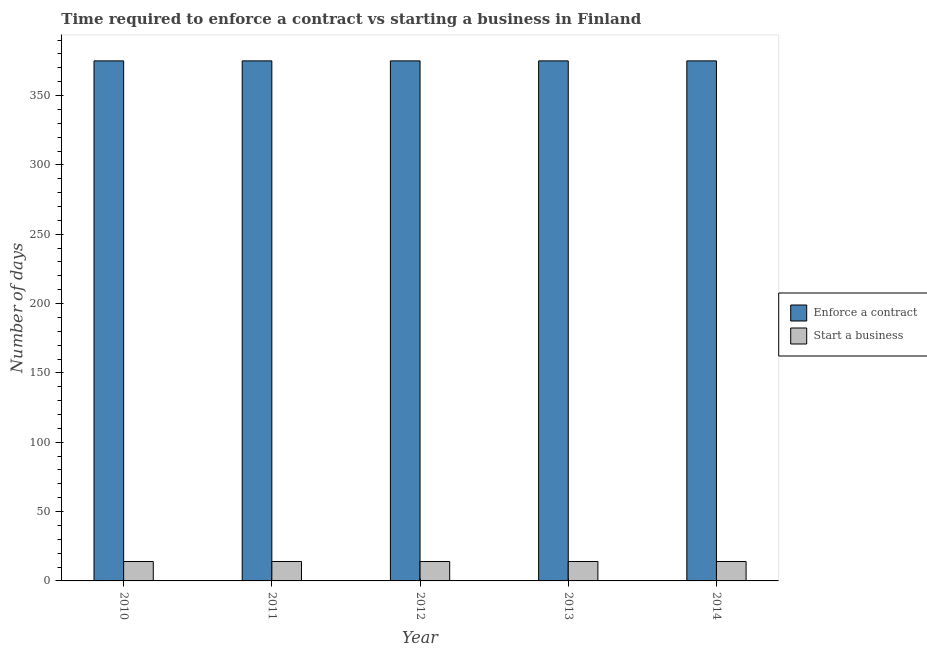What is the label of the 5th group of bars from the left?
Offer a very short reply. 2014. In how many cases, is the number of bars for a given year not equal to the number of legend labels?
Give a very brief answer. 0. What is the number of days to enforece a contract in 2014?
Your answer should be very brief. 375. Across all years, what is the maximum number of days to enforece a contract?
Offer a very short reply. 375. Across all years, what is the minimum number of days to start a business?
Your response must be concise. 14. In which year was the number of days to enforece a contract maximum?
Provide a short and direct response. 2010. What is the total number of days to start a business in the graph?
Offer a very short reply. 70. What is the difference between the number of days to start a business in 2013 and the number of days to enforece a contract in 2014?
Offer a terse response. 0. What is the average number of days to enforece a contract per year?
Your answer should be very brief. 375. In how many years, is the number of days to start a business greater than 300 days?
Keep it short and to the point. 0. Is the number of days to enforece a contract in 2011 less than that in 2013?
Offer a terse response. No. Is the difference between the number of days to start a business in 2010 and 2012 greater than the difference between the number of days to enforece a contract in 2010 and 2012?
Provide a succinct answer. No. What is the difference between the highest and the second highest number of days to start a business?
Keep it short and to the point. 0. What is the difference between the highest and the lowest number of days to start a business?
Your answer should be compact. 0. Is the sum of the number of days to enforece a contract in 2012 and 2013 greater than the maximum number of days to start a business across all years?
Your answer should be very brief. Yes. What does the 2nd bar from the left in 2011 represents?
Your response must be concise. Start a business. What does the 1st bar from the right in 2014 represents?
Provide a short and direct response. Start a business. How many bars are there?
Provide a short and direct response. 10. How many years are there in the graph?
Your answer should be very brief. 5. What is the difference between two consecutive major ticks on the Y-axis?
Your response must be concise. 50. Does the graph contain grids?
Your answer should be very brief. No. Where does the legend appear in the graph?
Your answer should be very brief. Center right. How are the legend labels stacked?
Offer a terse response. Vertical. What is the title of the graph?
Keep it short and to the point. Time required to enforce a contract vs starting a business in Finland. What is the label or title of the Y-axis?
Your answer should be very brief. Number of days. What is the Number of days of Enforce a contract in 2010?
Provide a succinct answer. 375. What is the Number of days in Enforce a contract in 2011?
Your response must be concise. 375. What is the Number of days of Start a business in 2011?
Your response must be concise. 14. What is the Number of days in Enforce a contract in 2012?
Your response must be concise. 375. What is the Number of days of Start a business in 2012?
Ensure brevity in your answer.  14. What is the Number of days in Enforce a contract in 2013?
Provide a succinct answer. 375. What is the Number of days of Enforce a contract in 2014?
Make the answer very short. 375. Across all years, what is the maximum Number of days of Enforce a contract?
Your response must be concise. 375. Across all years, what is the maximum Number of days in Start a business?
Your answer should be very brief. 14. Across all years, what is the minimum Number of days of Enforce a contract?
Make the answer very short. 375. Across all years, what is the minimum Number of days in Start a business?
Ensure brevity in your answer.  14. What is the total Number of days in Enforce a contract in the graph?
Keep it short and to the point. 1875. What is the difference between the Number of days of Enforce a contract in 2010 and that in 2011?
Offer a very short reply. 0. What is the difference between the Number of days in Start a business in 2010 and that in 2012?
Keep it short and to the point. 0. What is the difference between the Number of days of Enforce a contract in 2010 and that in 2013?
Your response must be concise. 0. What is the difference between the Number of days in Start a business in 2010 and that in 2013?
Your answer should be very brief. 0. What is the difference between the Number of days of Enforce a contract in 2010 and that in 2014?
Your answer should be very brief. 0. What is the difference between the Number of days of Start a business in 2010 and that in 2014?
Keep it short and to the point. 0. What is the difference between the Number of days of Enforce a contract in 2011 and that in 2013?
Keep it short and to the point. 0. What is the difference between the Number of days in Start a business in 2011 and that in 2013?
Ensure brevity in your answer.  0. What is the difference between the Number of days in Enforce a contract in 2012 and that in 2013?
Ensure brevity in your answer.  0. What is the difference between the Number of days in Start a business in 2012 and that in 2013?
Your response must be concise. 0. What is the difference between the Number of days of Enforce a contract in 2010 and the Number of days of Start a business in 2011?
Provide a succinct answer. 361. What is the difference between the Number of days in Enforce a contract in 2010 and the Number of days in Start a business in 2012?
Give a very brief answer. 361. What is the difference between the Number of days in Enforce a contract in 2010 and the Number of days in Start a business in 2013?
Make the answer very short. 361. What is the difference between the Number of days in Enforce a contract in 2010 and the Number of days in Start a business in 2014?
Ensure brevity in your answer.  361. What is the difference between the Number of days in Enforce a contract in 2011 and the Number of days in Start a business in 2012?
Your answer should be compact. 361. What is the difference between the Number of days of Enforce a contract in 2011 and the Number of days of Start a business in 2013?
Your answer should be compact. 361. What is the difference between the Number of days in Enforce a contract in 2011 and the Number of days in Start a business in 2014?
Provide a short and direct response. 361. What is the difference between the Number of days of Enforce a contract in 2012 and the Number of days of Start a business in 2013?
Offer a terse response. 361. What is the difference between the Number of days in Enforce a contract in 2012 and the Number of days in Start a business in 2014?
Give a very brief answer. 361. What is the difference between the Number of days of Enforce a contract in 2013 and the Number of days of Start a business in 2014?
Your response must be concise. 361. What is the average Number of days of Enforce a contract per year?
Offer a terse response. 375. What is the average Number of days of Start a business per year?
Offer a very short reply. 14. In the year 2010, what is the difference between the Number of days of Enforce a contract and Number of days of Start a business?
Keep it short and to the point. 361. In the year 2011, what is the difference between the Number of days of Enforce a contract and Number of days of Start a business?
Make the answer very short. 361. In the year 2012, what is the difference between the Number of days of Enforce a contract and Number of days of Start a business?
Ensure brevity in your answer.  361. In the year 2013, what is the difference between the Number of days in Enforce a contract and Number of days in Start a business?
Give a very brief answer. 361. In the year 2014, what is the difference between the Number of days of Enforce a contract and Number of days of Start a business?
Give a very brief answer. 361. What is the ratio of the Number of days in Enforce a contract in 2010 to that in 2012?
Make the answer very short. 1. What is the ratio of the Number of days in Start a business in 2010 to that in 2012?
Offer a terse response. 1. What is the ratio of the Number of days in Enforce a contract in 2010 to that in 2013?
Keep it short and to the point. 1. What is the ratio of the Number of days in Start a business in 2010 to that in 2013?
Ensure brevity in your answer.  1. What is the ratio of the Number of days in Enforce a contract in 2010 to that in 2014?
Provide a succinct answer. 1. What is the ratio of the Number of days of Start a business in 2011 to that in 2012?
Provide a short and direct response. 1. What is the ratio of the Number of days of Start a business in 2011 to that in 2013?
Your answer should be very brief. 1. What is the ratio of the Number of days of Enforce a contract in 2012 to that in 2013?
Offer a terse response. 1. What is the ratio of the Number of days of Start a business in 2012 to that in 2013?
Provide a short and direct response. 1. What is the ratio of the Number of days of Enforce a contract in 2012 to that in 2014?
Make the answer very short. 1. What is the ratio of the Number of days of Enforce a contract in 2013 to that in 2014?
Give a very brief answer. 1. 